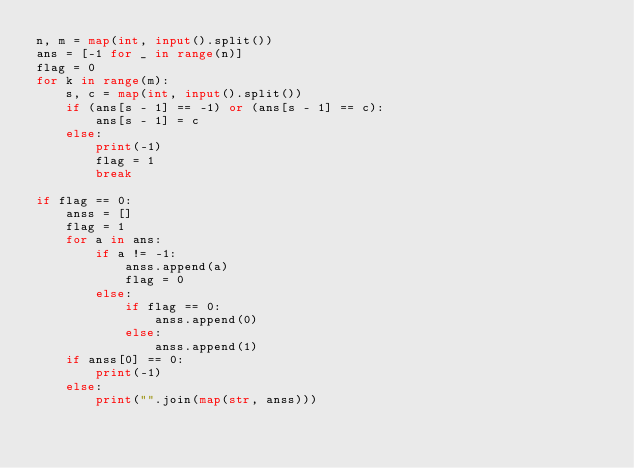Convert code to text. <code><loc_0><loc_0><loc_500><loc_500><_Python_>n, m = map(int, input().split())
ans = [-1 for _ in range(n)]
flag = 0
for k in range(m):
    s, c = map(int, input().split())
    if (ans[s - 1] == -1) or (ans[s - 1] == c):
        ans[s - 1] = c
    else:
        print(-1)
        flag = 1
        break

if flag == 0:
    anss = []
    flag = 1
    for a in ans:
        if a != -1:
            anss.append(a)
            flag = 0
        else:
            if flag == 0:
                anss.append(0)
            else:
                anss.append(1)
    if anss[0] == 0:
        print(-1)
    else:
        print("".join(map(str, anss)))</code> 